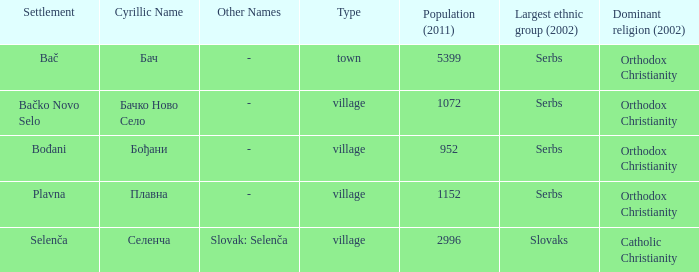What is the ethnic majority in the only town? Serbs. 